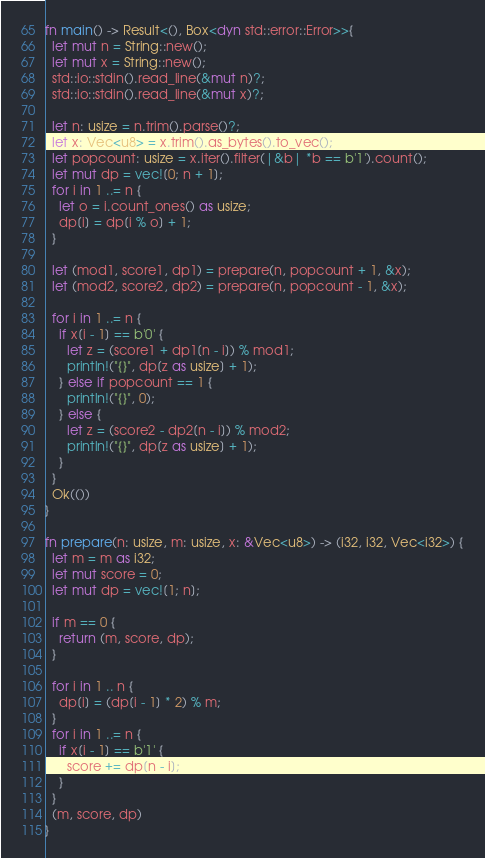<code> <loc_0><loc_0><loc_500><loc_500><_Rust_>fn main() -> Result<(), Box<dyn std::error::Error>>{
  let mut n = String::new();
  let mut x = String::new();
  std::io::stdin().read_line(&mut n)?;
  std::io::stdin().read_line(&mut x)?;
  
  let n: usize = n.trim().parse()?;
  let x: Vec<u8> = x.trim().as_bytes().to_vec();
  let popcount: usize = x.iter().filter(|&b| *b == b'1').count();
  let mut dp = vec![0; n + 1];
  for i in 1 ..= n {
    let o = i.count_ones() as usize;
    dp[i] = dp[i % o] + 1;
  }

  let (mod1, score1, dp1) = prepare(n, popcount + 1, &x);
  let (mod2, score2, dp2) = prepare(n, popcount - 1, &x);
  
  for i in 1 ..= n {
    if x[i - 1] == b'0' {
      let z = (score1 + dp1[n - i]) % mod1;
      println!("{}", dp[z as usize] + 1);
    } else if popcount == 1 {
      println!("{}", 0);
    } else {
      let z = (score2 - dp2[n - i]) % mod2;
      println!("{}", dp[z as usize] + 1);
    }
  }
  Ok(())
}

fn prepare(n: usize, m: usize, x: &Vec<u8>) -> (i32, i32, Vec<i32>) {
  let m = m as i32;
  let mut score = 0;
  let mut dp = vec![1; n];

  if m == 0 {
    return (m, score, dp);
  }
  
  for i in 1 .. n {
    dp[i] = (dp[i - 1] * 2) % m;
  }
  for i in 1 ..= n {
    if x[i - 1] == b'1' {
      score += dp[n - i];
    }
  }
  (m, score, dp)
}
</code> 